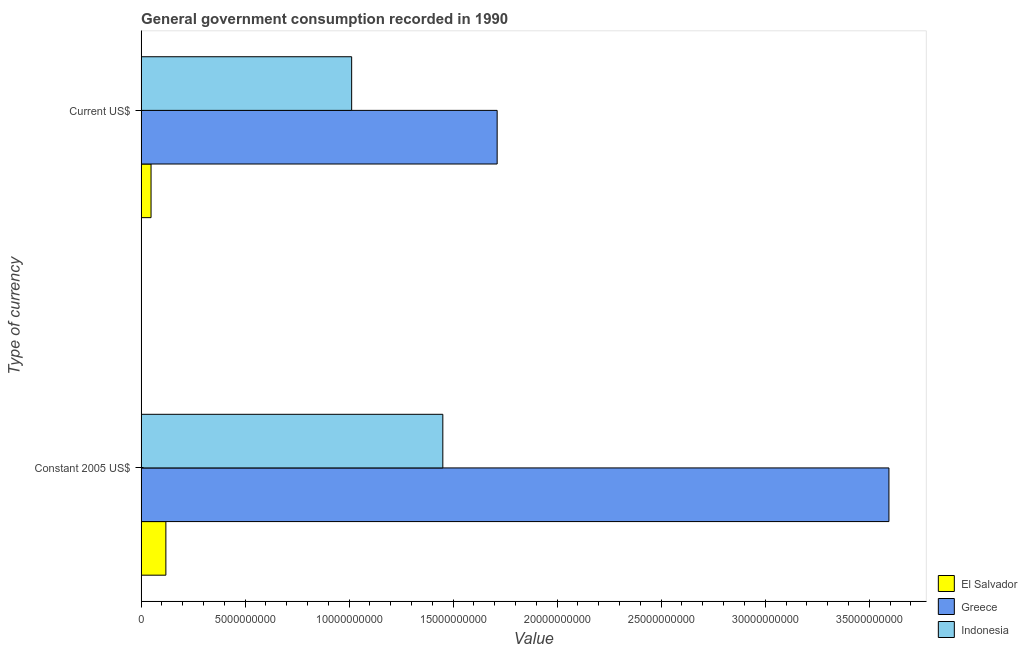How many groups of bars are there?
Provide a succinct answer. 2. Are the number of bars per tick equal to the number of legend labels?
Give a very brief answer. Yes. Are the number of bars on each tick of the Y-axis equal?
Provide a succinct answer. Yes. How many bars are there on the 1st tick from the bottom?
Your answer should be compact. 3. What is the label of the 1st group of bars from the top?
Your answer should be very brief. Current US$. What is the value consumed in constant 2005 us$ in Indonesia?
Offer a very short reply. 1.45e+1. Across all countries, what is the maximum value consumed in constant 2005 us$?
Offer a very short reply. 3.59e+1. Across all countries, what is the minimum value consumed in current us$?
Your answer should be compact. 4.76e+08. In which country was the value consumed in current us$ maximum?
Offer a very short reply. Greece. In which country was the value consumed in constant 2005 us$ minimum?
Give a very brief answer. El Salvador. What is the total value consumed in constant 2005 us$ in the graph?
Provide a short and direct response. 5.16e+1. What is the difference between the value consumed in constant 2005 us$ in Indonesia and that in El Salvador?
Ensure brevity in your answer.  1.33e+1. What is the difference between the value consumed in constant 2005 us$ in Greece and the value consumed in current us$ in Indonesia?
Your answer should be very brief. 2.58e+1. What is the average value consumed in constant 2005 us$ per country?
Offer a terse response. 1.72e+1. What is the difference between the value consumed in constant 2005 us$ and value consumed in current us$ in Greece?
Ensure brevity in your answer.  1.88e+1. What is the ratio of the value consumed in constant 2005 us$ in Greece to that in Indonesia?
Your response must be concise. 2.48. Is the value consumed in constant 2005 us$ in El Salvador less than that in Indonesia?
Offer a terse response. Yes. In how many countries, is the value consumed in constant 2005 us$ greater than the average value consumed in constant 2005 us$ taken over all countries?
Provide a succinct answer. 1. What does the 2nd bar from the bottom in Current US$ represents?
Provide a short and direct response. Greece. How many bars are there?
Your answer should be compact. 6. How many countries are there in the graph?
Your response must be concise. 3. What is the difference between two consecutive major ticks on the X-axis?
Make the answer very short. 5.00e+09. Are the values on the major ticks of X-axis written in scientific E-notation?
Provide a succinct answer. No. Does the graph contain any zero values?
Your answer should be very brief. No. Does the graph contain grids?
Provide a succinct answer. No. Where does the legend appear in the graph?
Provide a succinct answer. Bottom right. How are the legend labels stacked?
Offer a terse response. Vertical. What is the title of the graph?
Make the answer very short. General government consumption recorded in 1990. Does "Senegal" appear as one of the legend labels in the graph?
Your response must be concise. No. What is the label or title of the X-axis?
Your answer should be compact. Value. What is the label or title of the Y-axis?
Provide a short and direct response. Type of currency. What is the Value in El Salvador in Constant 2005 US$?
Your answer should be compact. 1.19e+09. What is the Value of Greece in Constant 2005 US$?
Your answer should be compact. 3.59e+1. What is the Value of Indonesia in Constant 2005 US$?
Provide a short and direct response. 1.45e+1. What is the Value of El Salvador in Current US$?
Make the answer very short. 4.76e+08. What is the Value in Greece in Current US$?
Offer a very short reply. 1.71e+1. What is the Value in Indonesia in Current US$?
Make the answer very short. 1.01e+1. Across all Type of currency, what is the maximum Value in El Salvador?
Offer a terse response. 1.19e+09. Across all Type of currency, what is the maximum Value in Greece?
Ensure brevity in your answer.  3.59e+1. Across all Type of currency, what is the maximum Value in Indonesia?
Your answer should be compact. 1.45e+1. Across all Type of currency, what is the minimum Value in El Salvador?
Give a very brief answer. 4.76e+08. Across all Type of currency, what is the minimum Value of Greece?
Offer a terse response. 1.71e+1. Across all Type of currency, what is the minimum Value in Indonesia?
Ensure brevity in your answer.  1.01e+1. What is the total Value of El Salvador in the graph?
Ensure brevity in your answer.  1.66e+09. What is the total Value of Greece in the graph?
Offer a terse response. 5.31e+1. What is the total Value in Indonesia in the graph?
Provide a succinct answer. 2.46e+1. What is the difference between the Value of El Salvador in Constant 2005 US$ and that in Current US$?
Ensure brevity in your answer.  7.13e+08. What is the difference between the Value of Greece in Constant 2005 US$ and that in Current US$?
Provide a short and direct response. 1.88e+1. What is the difference between the Value in Indonesia in Constant 2005 US$ and that in Current US$?
Give a very brief answer. 4.38e+09. What is the difference between the Value of El Salvador in Constant 2005 US$ and the Value of Greece in Current US$?
Provide a short and direct response. -1.59e+1. What is the difference between the Value in El Salvador in Constant 2005 US$ and the Value in Indonesia in Current US$?
Make the answer very short. -8.93e+09. What is the difference between the Value of Greece in Constant 2005 US$ and the Value of Indonesia in Current US$?
Offer a terse response. 2.58e+1. What is the average Value of El Salvador per Type of currency?
Keep it short and to the point. 8.32e+08. What is the average Value of Greece per Type of currency?
Ensure brevity in your answer.  2.65e+1. What is the average Value in Indonesia per Type of currency?
Provide a succinct answer. 1.23e+1. What is the difference between the Value of El Salvador and Value of Greece in Constant 2005 US$?
Provide a short and direct response. -3.48e+1. What is the difference between the Value in El Salvador and Value in Indonesia in Constant 2005 US$?
Your answer should be very brief. -1.33e+1. What is the difference between the Value in Greece and Value in Indonesia in Constant 2005 US$?
Ensure brevity in your answer.  2.14e+1. What is the difference between the Value of El Salvador and Value of Greece in Current US$?
Provide a succinct answer. -1.66e+1. What is the difference between the Value of El Salvador and Value of Indonesia in Current US$?
Ensure brevity in your answer.  -9.64e+09. What is the difference between the Value in Greece and Value in Indonesia in Current US$?
Make the answer very short. 6.99e+09. What is the ratio of the Value of El Salvador in Constant 2005 US$ to that in Current US$?
Offer a terse response. 2.5. What is the ratio of the Value in Greece in Constant 2005 US$ to that in Current US$?
Offer a terse response. 2.1. What is the ratio of the Value of Indonesia in Constant 2005 US$ to that in Current US$?
Offer a terse response. 1.43. What is the difference between the highest and the second highest Value of El Salvador?
Provide a short and direct response. 7.13e+08. What is the difference between the highest and the second highest Value in Greece?
Ensure brevity in your answer.  1.88e+1. What is the difference between the highest and the second highest Value of Indonesia?
Offer a very short reply. 4.38e+09. What is the difference between the highest and the lowest Value of El Salvador?
Provide a succinct answer. 7.13e+08. What is the difference between the highest and the lowest Value in Greece?
Provide a succinct answer. 1.88e+1. What is the difference between the highest and the lowest Value in Indonesia?
Provide a succinct answer. 4.38e+09. 